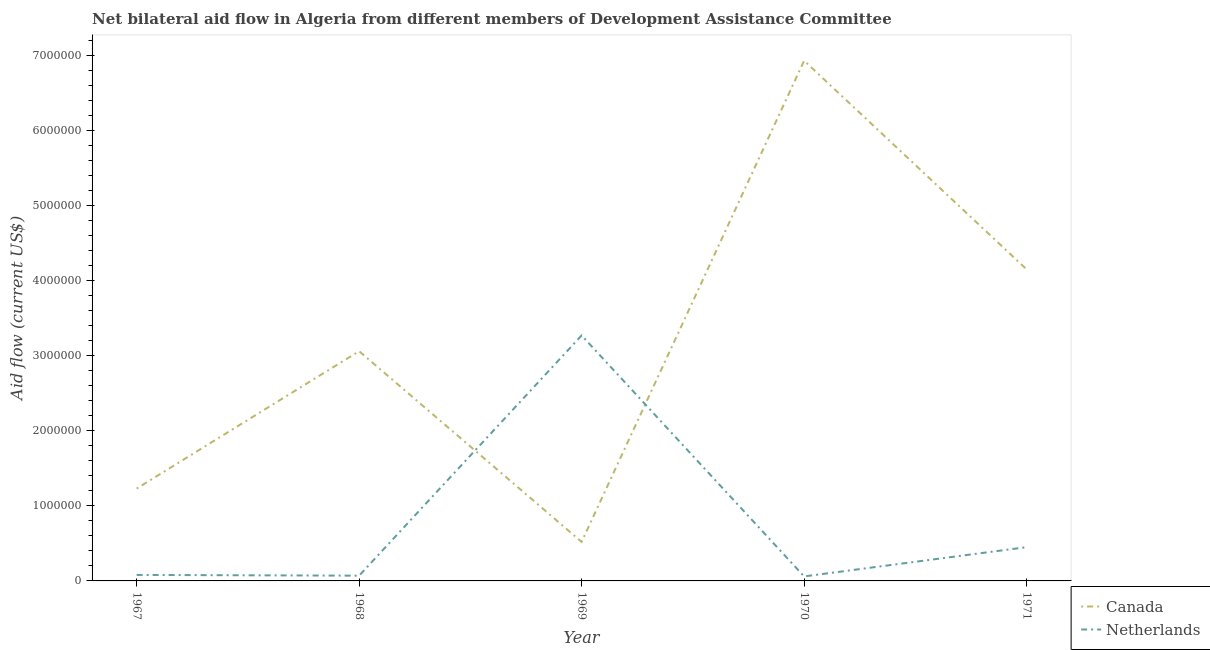Is the number of lines equal to the number of legend labels?
Keep it short and to the point. Yes. What is the amount of aid given by netherlands in 1967?
Your answer should be compact. 8.00e+04. Across all years, what is the maximum amount of aid given by netherlands?
Offer a terse response. 3.27e+06. Across all years, what is the minimum amount of aid given by netherlands?
Offer a very short reply. 6.00e+04. In which year was the amount of aid given by netherlands maximum?
Your answer should be very brief. 1969. In which year was the amount of aid given by canada minimum?
Offer a very short reply. 1969. What is the total amount of aid given by netherlands in the graph?
Give a very brief answer. 3.93e+06. What is the difference between the amount of aid given by canada in 1968 and that in 1969?
Provide a succinct answer. 2.54e+06. What is the difference between the amount of aid given by canada in 1970 and the amount of aid given by netherlands in 1967?
Provide a short and direct response. 6.85e+06. What is the average amount of aid given by netherlands per year?
Offer a terse response. 7.86e+05. In the year 1970, what is the difference between the amount of aid given by canada and amount of aid given by netherlands?
Your answer should be very brief. 6.87e+06. What is the ratio of the amount of aid given by netherlands in 1968 to that in 1969?
Offer a terse response. 0.02. Is the amount of aid given by canada in 1969 less than that in 1971?
Offer a very short reply. Yes. Is the difference between the amount of aid given by canada in 1968 and 1970 greater than the difference between the amount of aid given by netherlands in 1968 and 1970?
Offer a very short reply. No. What is the difference between the highest and the second highest amount of aid given by netherlands?
Keep it short and to the point. 2.82e+06. What is the difference between the highest and the lowest amount of aid given by netherlands?
Give a very brief answer. 3.21e+06. In how many years, is the amount of aid given by netherlands greater than the average amount of aid given by netherlands taken over all years?
Make the answer very short. 1. Is the amount of aid given by canada strictly less than the amount of aid given by netherlands over the years?
Make the answer very short. No. What is the difference between two consecutive major ticks on the Y-axis?
Provide a short and direct response. 1.00e+06. Does the graph contain any zero values?
Your answer should be very brief. No. Does the graph contain grids?
Make the answer very short. No. How are the legend labels stacked?
Ensure brevity in your answer.  Vertical. What is the title of the graph?
Keep it short and to the point. Net bilateral aid flow in Algeria from different members of Development Assistance Committee. Does "Commercial bank branches" appear as one of the legend labels in the graph?
Make the answer very short. No. What is the label or title of the X-axis?
Provide a short and direct response. Year. What is the Aid flow (current US$) in Canada in 1967?
Ensure brevity in your answer.  1.23e+06. What is the Aid flow (current US$) in Netherlands in 1967?
Offer a terse response. 8.00e+04. What is the Aid flow (current US$) in Canada in 1968?
Your response must be concise. 3.06e+06. What is the Aid flow (current US$) of Netherlands in 1968?
Provide a short and direct response. 7.00e+04. What is the Aid flow (current US$) in Canada in 1969?
Provide a succinct answer. 5.20e+05. What is the Aid flow (current US$) of Netherlands in 1969?
Offer a very short reply. 3.27e+06. What is the Aid flow (current US$) of Canada in 1970?
Your answer should be compact. 6.93e+06. What is the Aid flow (current US$) of Canada in 1971?
Your response must be concise. 4.15e+06. What is the Aid flow (current US$) in Netherlands in 1971?
Keep it short and to the point. 4.50e+05. Across all years, what is the maximum Aid flow (current US$) in Canada?
Give a very brief answer. 6.93e+06. Across all years, what is the maximum Aid flow (current US$) in Netherlands?
Your response must be concise. 3.27e+06. Across all years, what is the minimum Aid flow (current US$) in Canada?
Offer a very short reply. 5.20e+05. What is the total Aid flow (current US$) in Canada in the graph?
Your response must be concise. 1.59e+07. What is the total Aid flow (current US$) of Netherlands in the graph?
Provide a succinct answer. 3.93e+06. What is the difference between the Aid flow (current US$) in Canada in 1967 and that in 1968?
Your answer should be very brief. -1.83e+06. What is the difference between the Aid flow (current US$) of Canada in 1967 and that in 1969?
Make the answer very short. 7.10e+05. What is the difference between the Aid flow (current US$) of Netherlands in 1967 and that in 1969?
Your response must be concise. -3.19e+06. What is the difference between the Aid flow (current US$) in Canada in 1967 and that in 1970?
Your response must be concise. -5.70e+06. What is the difference between the Aid flow (current US$) of Netherlands in 1967 and that in 1970?
Offer a terse response. 2.00e+04. What is the difference between the Aid flow (current US$) of Canada in 1967 and that in 1971?
Offer a terse response. -2.92e+06. What is the difference between the Aid flow (current US$) in Netherlands in 1967 and that in 1971?
Give a very brief answer. -3.70e+05. What is the difference between the Aid flow (current US$) in Canada in 1968 and that in 1969?
Give a very brief answer. 2.54e+06. What is the difference between the Aid flow (current US$) of Netherlands in 1968 and that in 1969?
Offer a very short reply. -3.20e+06. What is the difference between the Aid flow (current US$) in Canada in 1968 and that in 1970?
Provide a short and direct response. -3.87e+06. What is the difference between the Aid flow (current US$) in Canada in 1968 and that in 1971?
Provide a succinct answer. -1.09e+06. What is the difference between the Aid flow (current US$) of Netherlands in 1968 and that in 1971?
Ensure brevity in your answer.  -3.80e+05. What is the difference between the Aid flow (current US$) in Canada in 1969 and that in 1970?
Give a very brief answer. -6.41e+06. What is the difference between the Aid flow (current US$) in Netherlands in 1969 and that in 1970?
Your answer should be compact. 3.21e+06. What is the difference between the Aid flow (current US$) of Canada in 1969 and that in 1971?
Provide a succinct answer. -3.63e+06. What is the difference between the Aid flow (current US$) of Netherlands in 1969 and that in 1971?
Provide a succinct answer. 2.82e+06. What is the difference between the Aid flow (current US$) of Canada in 1970 and that in 1971?
Keep it short and to the point. 2.78e+06. What is the difference between the Aid flow (current US$) in Netherlands in 1970 and that in 1971?
Make the answer very short. -3.90e+05. What is the difference between the Aid flow (current US$) of Canada in 1967 and the Aid flow (current US$) of Netherlands in 1968?
Give a very brief answer. 1.16e+06. What is the difference between the Aid flow (current US$) of Canada in 1967 and the Aid flow (current US$) of Netherlands in 1969?
Your response must be concise. -2.04e+06. What is the difference between the Aid flow (current US$) in Canada in 1967 and the Aid flow (current US$) in Netherlands in 1970?
Keep it short and to the point. 1.17e+06. What is the difference between the Aid flow (current US$) in Canada in 1967 and the Aid flow (current US$) in Netherlands in 1971?
Provide a succinct answer. 7.80e+05. What is the difference between the Aid flow (current US$) in Canada in 1968 and the Aid flow (current US$) in Netherlands in 1969?
Ensure brevity in your answer.  -2.10e+05. What is the difference between the Aid flow (current US$) of Canada in 1968 and the Aid flow (current US$) of Netherlands in 1971?
Your answer should be compact. 2.61e+06. What is the difference between the Aid flow (current US$) in Canada in 1969 and the Aid flow (current US$) in Netherlands in 1970?
Give a very brief answer. 4.60e+05. What is the difference between the Aid flow (current US$) of Canada in 1970 and the Aid flow (current US$) of Netherlands in 1971?
Ensure brevity in your answer.  6.48e+06. What is the average Aid flow (current US$) in Canada per year?
Ensure brevity in your answer.  3.18e+06. What is the average Aid flow (current US$) in Netherlands per year?
Make the answer very short. 7.86e+05. In the year 1967, what is the difference between the Aid flow (current US$) of Canada and Aid flow (current US$) of Netherlands?
Ensure brevity in your answer.  1.15e+06. In the year 1968, what is the difference between the Aid flow (current US$) in Canada and Aid flow (current US$) in Netherlands?
Make the answer very short. 2.99e+06. In the year 1969, what is the difference between the Aid flow (current US$) in Canada and Aid flow (current US$) in Netherlands?
Provide a succinct answer. -2.75e+06. In the year 1970, what is the difference between the Aid flow (current US$) in Canada and Aid flow (current US$) in Netherlands?
Your answer should be very brief. 6.87e+06. In the year 1971, what is the difference between the Aid flow (current US$) in Canada and Aid flow (current US$) in Netherlands?
Provide a succinct answer. 3.70e+06. What is the ratio of the Aid flow (current US$) of Canada in 1967 to that in 1968?
Keep it short and to the point. 0.4. What is the ratio of the Aid flow (current US$) in Netherlands in 1967 to that in 1968?
Your answer should be compact. 1.14. What is the ratio of the Aid flow (current US$) of Canada in 1967 to that in 1969?
Your answer should be very brief. 2.37. What is the ratio of the Aid flow (current US$) in Netherlands in 1967 to that in 1969?
Keep it short and to the point. 0.02. What is the ratio of the Aid flow (current US$) of Canada in 1967 to that in 1970?
Your response must be concise. 0.18. What is the ratio of the Aid flow (current US$) of Canada in 1967 to that in 1971?
Your response must be concise. 0.3. What is the ratio of the Aid flow (current US$) in Netherlands in 1967 to that in 1971?
Make the answer very short. 0.18. What is the ratio of the Aid flow (current US$) in Canada in 1968 to that in 1969?
Provide a succinct answer. 5.88. What is the ratio of the Aid flow (current US$) of Netherlands in 1968 to that in 1969?
Your answer should be very brief. 0.02. What is the ratio of the Aid flow (current US$) of Canada in 1968 to that in 1970?
Make the answer very short. 0.44. What is the ratio of the Aid flow (current US$) of Canada in 1968 to that in 1971?
Provide a short and direct response. 0.74. What is the ratio of the Aid flow (current US$) in Netherlands in 1968 to that in 1971?
Your answer should be compact. 0.16. What is the ratio of the Aid flow (current US$) of Canada in 1969 to that in 1970?
Your response must be concise. 0.07. What is the ratio of the Aid flow (current US$) of Netherlands in 1969 to that in 1970?
Your answer should be compact. 54.5. What is the ratio of the Aid flow (current US$) of Canada in 1969 to that in 1971?
Provide a succinct answer. 0.13. What is the ratio of the Aid flow (current US$) in Netherlands in 1969 to that in 1971?
Offer a terse response. 7.27. What is the ratio of the Aid flow (current US$) in Canada in 1970 to that in 1971?
Keep it short and to the point. 1.67. What is the ratio of the Aid flow (current US$) in Netherlands in 1970 to that in 1971?
Ensure brevity in your answer.  0.13. What is the difference between the highest and the second highest Aid flow (current US$) in Canada?
Offer a very short reply. 2.78e+06. What is the difference between the highest and the second highest Aid flow (current US$) in Netherlands?
Keep it short and to the point. 2.82e+06. What is the difference between the highest and the lowest Aid flow (current US$) of Canada?
Provide a succinct answer. 6.41e+06. What is the difference between the highest and the lowest Aid flow (current US$) in Netherlands?
Your response must be concise. 3.21e+06. 